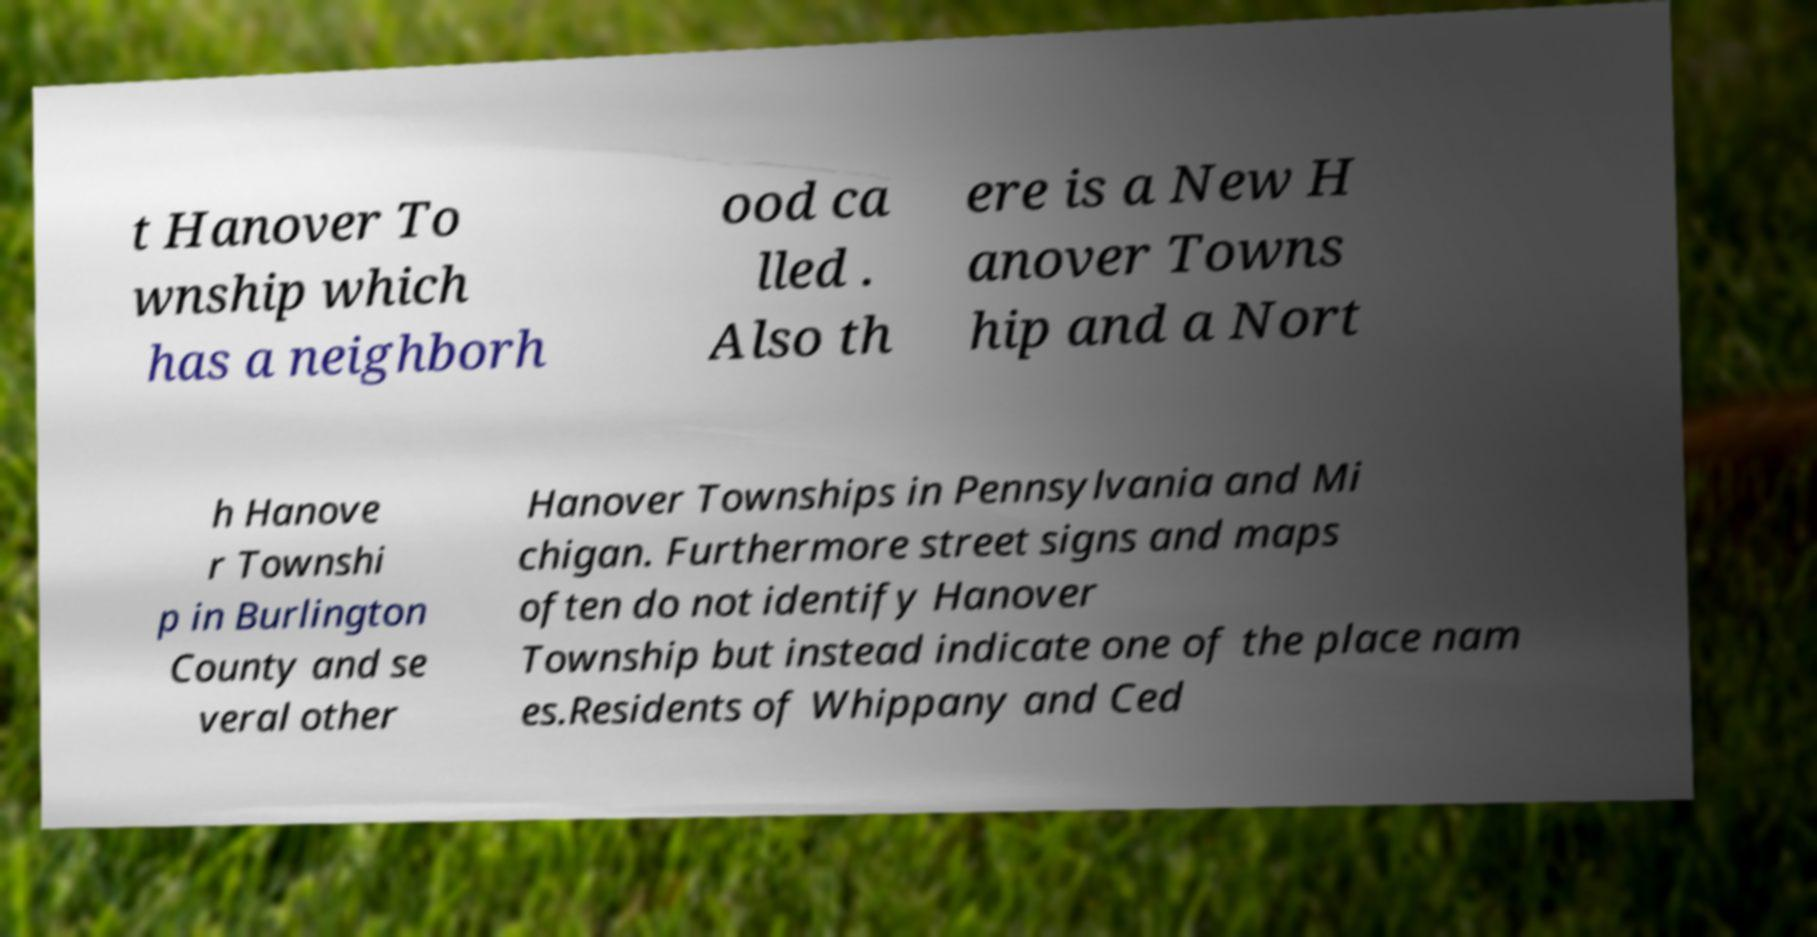Please read and relay the text visible in this image. What does it say? t Hanover To wnship which has a neighborh ood ca lled . Also th ere is a New H anover Towns hip and a Nort h Hanove r Townshi p in Burlington County and se veral other Hanover Townships in Pennsylvania and Mi chigan. Furthermore street signs and maps often do not identify Hanover Township but instead indicate one of the place nam es.Residents of Whippany and Ced 